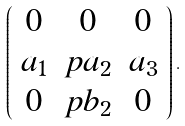Convert formula to latex. <formula><loc_0><loc_0><loc_500><loc_500>\left ( \begin{array} { c c c } 0 & 0 & 0 \\ a _ { 1 } & p a _ { 2 } & a _ { 3 } \\ 0 & p b _ { 2 } & 0 \end{array} \right ) .</formula> 